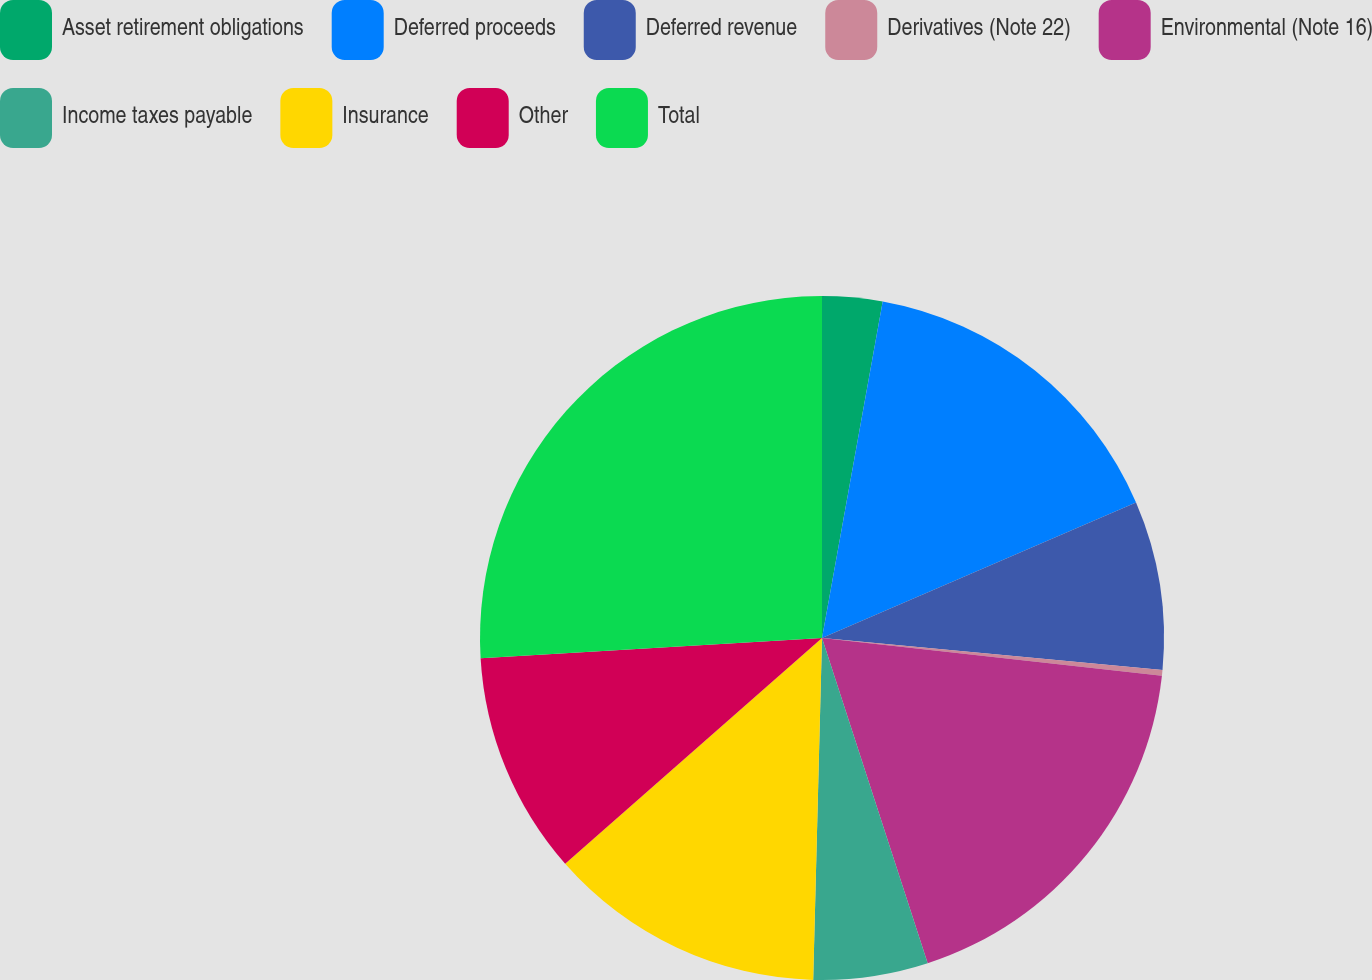Convert chart to OTSL. <chart><loc_0><loc_0><loc_500><loc_500><pie_chart><fcel>Asset retirement obligations<fcel>Deferred proceeds<fcel>Deferred revenue<fcel>Derivatives (Note 22)<fcel>Environmental (Note 16)<fcel>Income taxes payable<fcel>Insurance<fcel>Other<fcel>Total<nl><fcel>2.84%<fcel>15.68%<fcel>7.97%<fcel>0.27%<fcel>18.24%<fcel>5.41%<fcel>13.11%<fcel>10.54%<fcel>25.94%<nl></chart> 